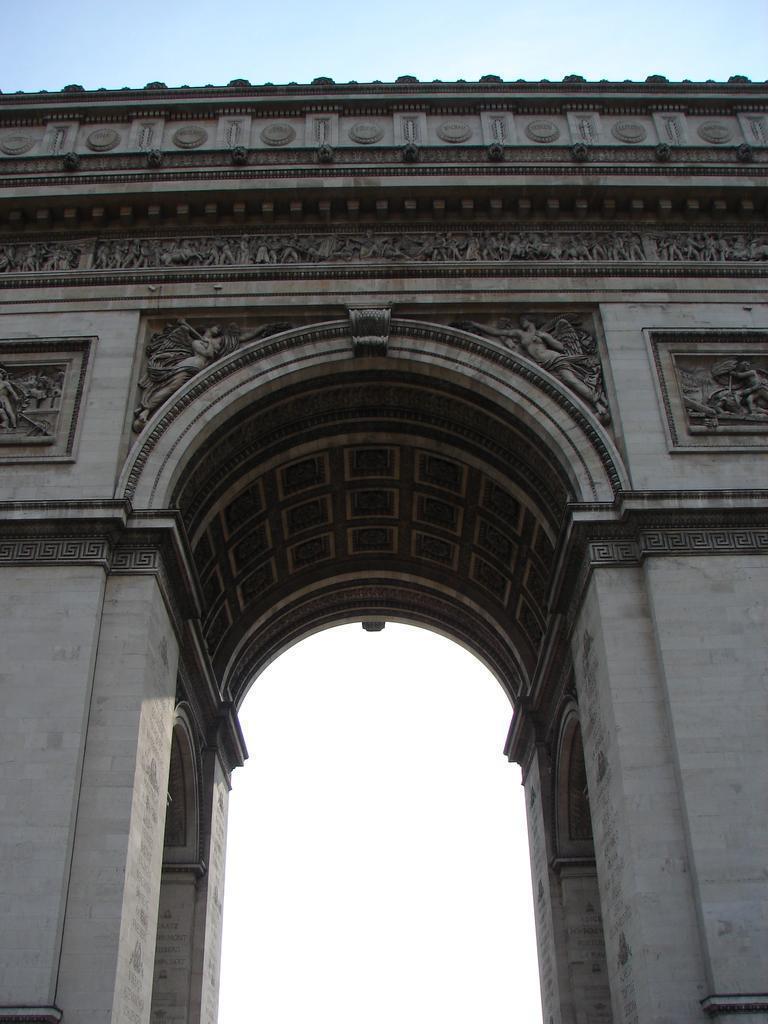Please provide a concise description of this image. As we can see in the image there is a wall, sculptures and on the top there is a sky. 